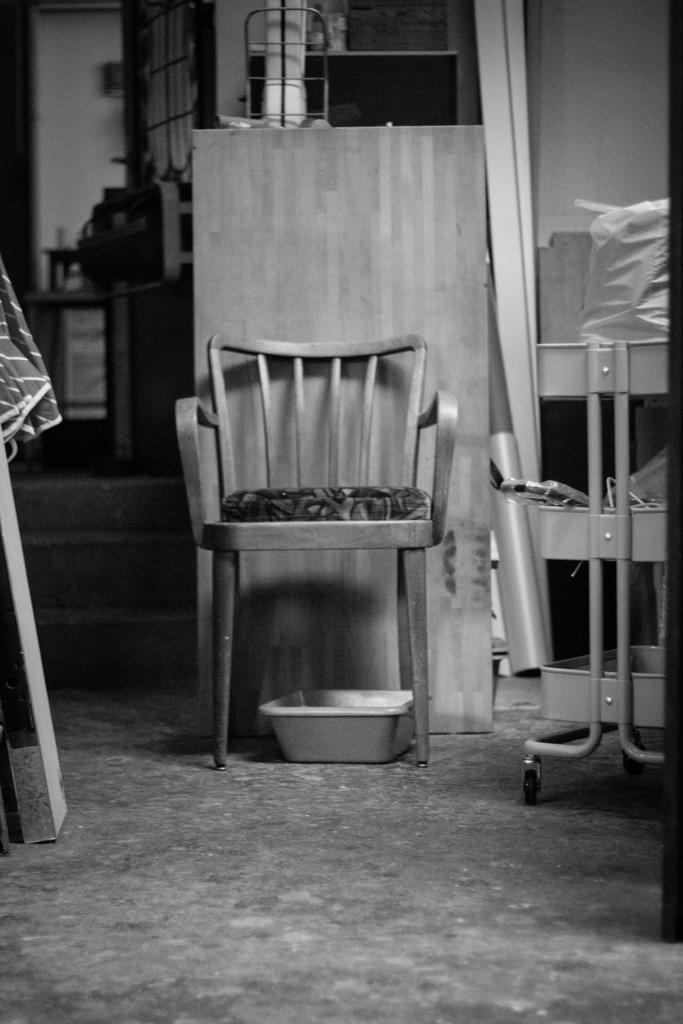What type of furniture is present in the image? There is a chair in the image. What kitchen item can be seen in the image? There is a pan in the image. Can you describe any other objects visible in the image? There are additional objects in the background of the image, but their specific details are not provided. What type of mist can be seen surrounding the chair in the image? There is no mist present in the image; it is not mentioned in the provided facts. 